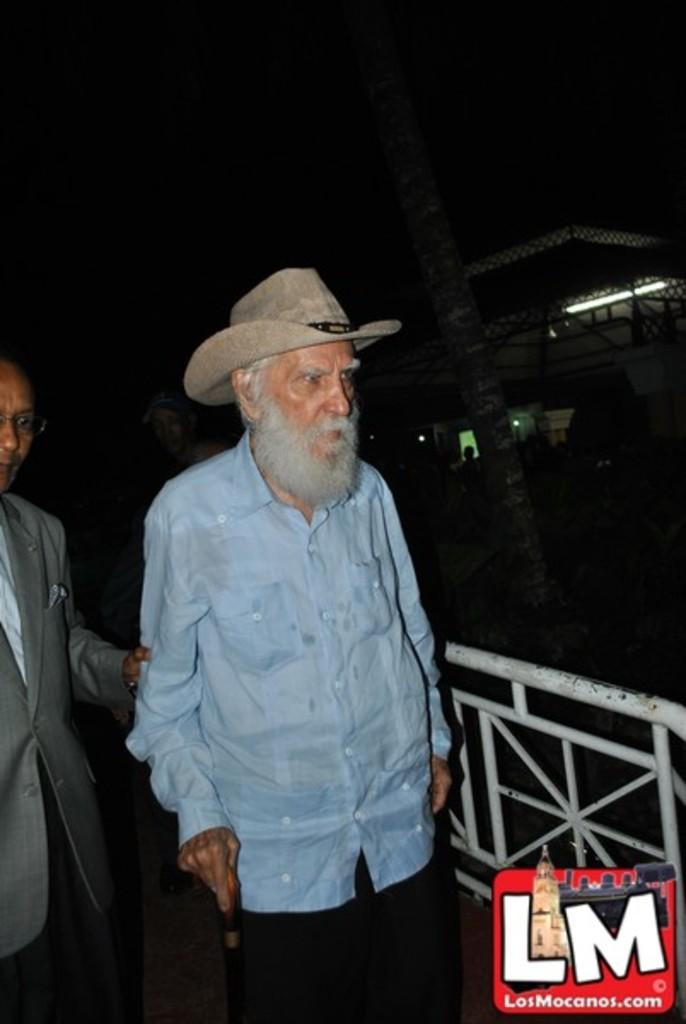How many people are visible in the image? There are two persons in the front of the image. What can be seen in the background of the image? There is a building and light in the background of the image. Can you describe the overall lighting condition of the image? The image is slightly dark. Is there a tent visible in the image? No, there is no tent present in the image. What type of precipitation can be seen falling from the sky in the image? There is no precipitation visible in the image, including sleet. 